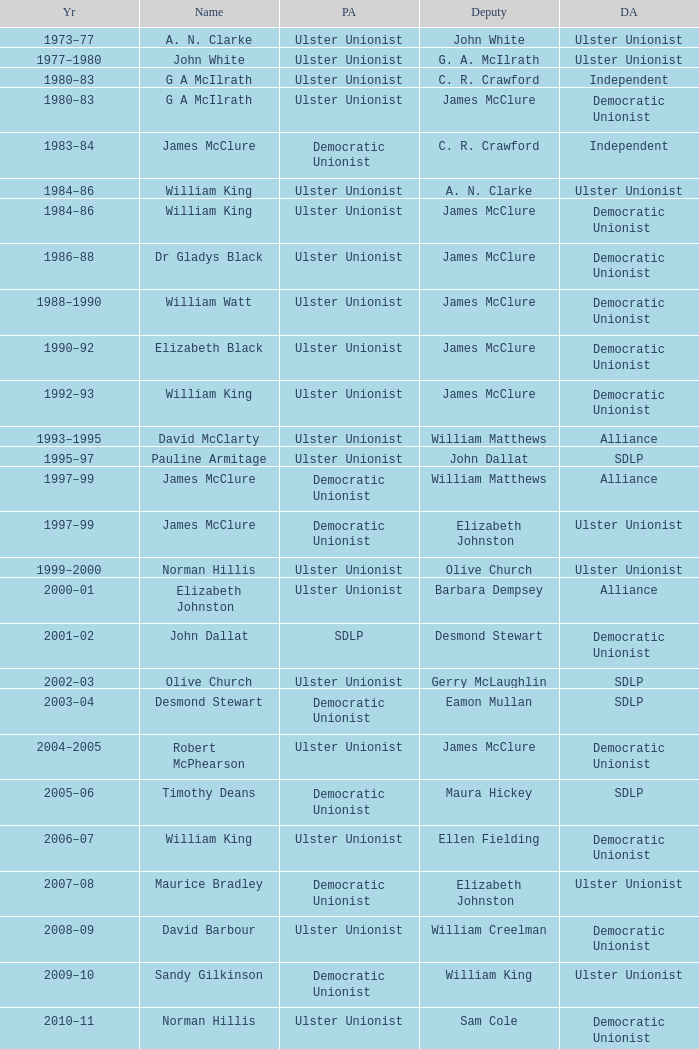What is the Deputy's affiliation in 1992–93? Democratic Unionist. Could you parse the entire table as a dict? {'header': ['Yr', 'Name', 'PA', 'Deputy', 'DA'], 'rows': [['1973–77', 'A. N. Clarke', 'Ulster Unionist', 'John White', 'Ulster Unionist'], ['1977–1980', 'John White', 'Ulster Unionist', 'G. A. McIlrath', 'Ulster Unionist'], ['1980–83', 'G A McIlrath', 'Ulster Unionist', 'C. R. Crawford', 'Independent'], ['1980–83', 'G A McIlrath', 'Ulster Unionist', 'James McClure', 'Democratic Unionist'], ['1983–84', 'James McClure', 'Democratic Unionist', 'C. R. Crawford', 'Independent'], ['1984–86', 'William King', 'Ulster Unionist', 'A. N. Clarke', 'Ulster Unionist'], ['1984–86', 'William King', 'Ulster Unionist', 'James McClure', 'Democratic Unionist'], ['1986–88', 'Dr Gladys Black', 'Ulster Unionist', 'James McClure', 'Democratic Unionist'], ['1988–1990', 'William Watt', 'Ulster Unionist', 'James McClure', 'Democratic Unionist'], ['1990–92', 'Elizabeth Black', 'Ulster Unionist', 'James McClure', 'Democratic Unionist'], ['1992–93', 'William King', 'Ulster Unionist', 'James McClure', 'Democratic Unionist'], ['1993–1995', 'David McClarty', 'Ulster Unionist', 'William Matthews', 'Alliance'], ['1995–97', 'Pauline Armitage', 'Ulster Unionist', 'John Dallat', 'SDLP'], ['1997–99', 'James McClure', 'Democratic Unionist', 'William Matthews', 'Alliance'], ['1997–99', 'James McClure', 'Democratic Unionist', 'Elizabeth Johnston', 'Ulster Unionist'], ['1999–2000', 'Norman Hillis', 'Ulster Unionist', 'Olive Church', 'Ulster Unionist'], ['2000–01', 'Elizabeth Johnston', 'Ulster Unionist', 'Barbara Dempsey', 'Alliance'], ['2001–02', 'John Dallat', 'SDLP', 'Desmond Stewart', 'Democratic Unionist'], ['2002–03', 'Olive Church', 'Ulster Unionist', 'Gerry McLaughlin', 'SDLP'], ['2003–04', 'Desmond Stewart', 'Democratic Unionist', 'Eamon Mullan', 'SDLP'], ['2004–2005', 'Robert McPhearson', 'Ulster Unionist', 'James McClure', 'Democratic Unionist'], ['2005–06', 'Timothy Deans', 'Democratic Unionist', 'Maura Hickey', 'SDLP'], ['2006–07', 'William King', 'Ulster Unionist', 'Ellen Fielding', 'Democratic Unionist'], ['2007–08', 'Maurice Bradley', 'Democratic Unionist', 'Elizabeth Johnston', 'Ulster Unionist'], ['2008–09', 'David Barbour', 'Ulster Unionist', 'William Creelman', 'Democratic Unionist'], ['2009–10', 'Sandy Gilkinson', 'Democratic Unionist', 'William King', 'Ulster Unionist'], ['2010–11', 'Norman Hillis', 'Ulster Unionist', 'Sam Cole', 'Democratic Unionist'], ['2011–12', 'Maurice Bradley', 'Democratic Unionist', 'William King', 'Ulster Unionist'], ['2012–13', 'Sam Cole', 'Democratic Unionist', 'Maura Hickey', 'SDLP'], ['2013–14', 'David Harding', 'Ulster Unionist', 'Mark Fielding', 'Democratic Unionist']]} 